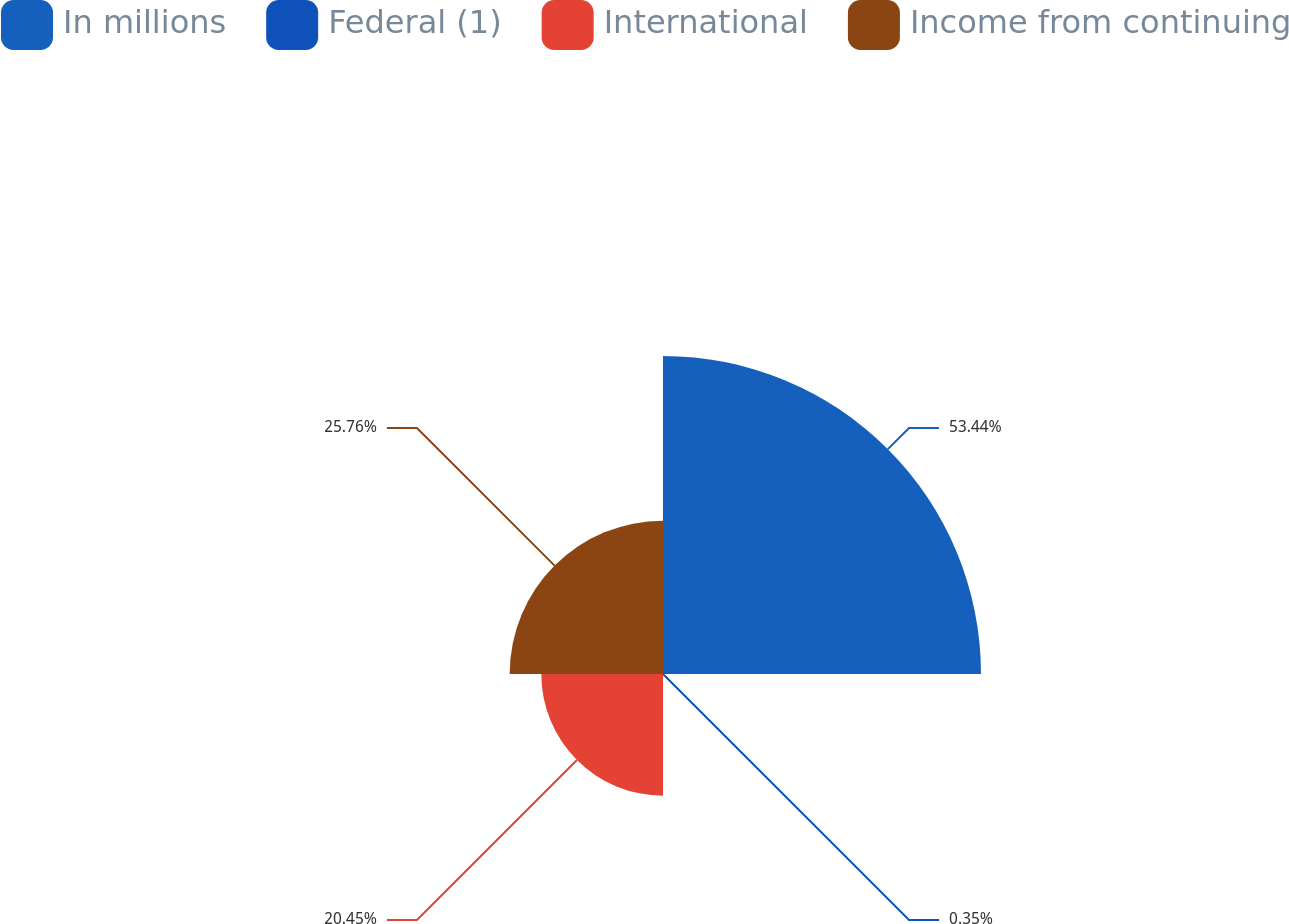Convert chart. <chart><loc_0><loc_0><loc_500><loc_500><pie_chart><fcel>In millions<fcel>Federal (1)<fcel>International<fcel>Income from continuing<nl><fcel>53.43%<fcel>0.35%<fcel>20.45%<fcel>25.76%<nl></chart> 